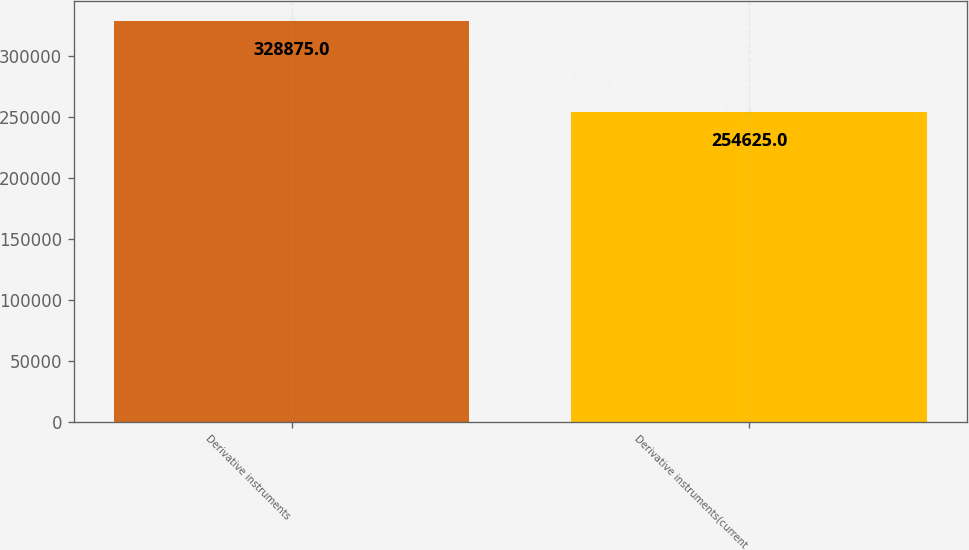Convert chart to OTSL. <chart><loc_0><loc_0><loc_500><loc_500><bar_chart><fcel>Derivative instruments<fcel>Derivative instruments(current<nl><fcel>328875<fcel>254625<nl></chart> 